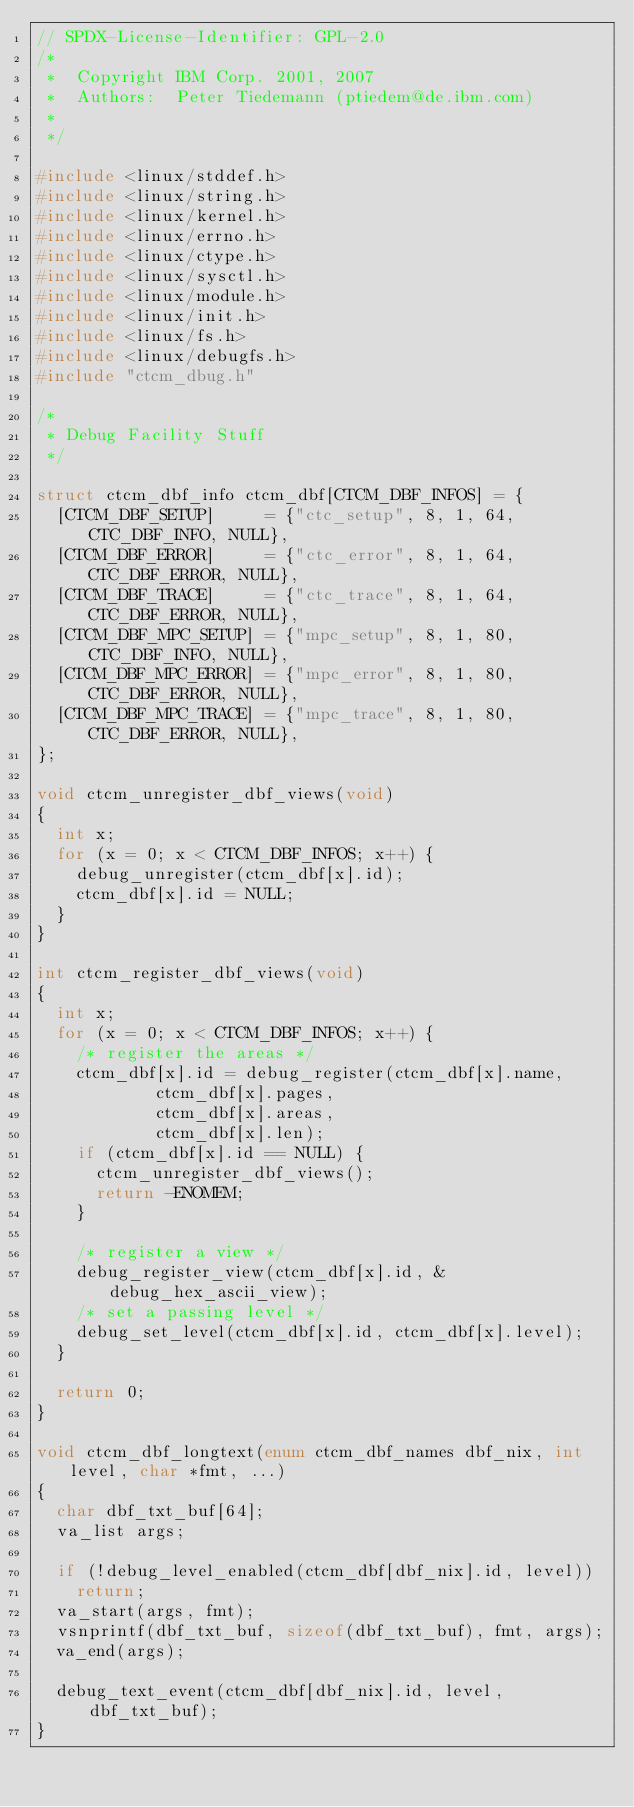<code> <loc_0><loc_0><loc_500><loc_500><_C_>// SPDX-License-Identifier: GPL-2.0
/*
 *	Copyright IBM Corp. 2001, 2007
 *	Authors:	Peter Tiedemann (ptiedem@de.ibm.com)
 *
 */

#include <linux/stddef.h>
#include <linux/string.h>
#include <linux/kernel.h>
#include <linux/errno.h>
#include <linux/ctype.h>
#include <linux/sysctl.h>
#include <linux/module.h>
#include <linux/init.h>
#include <linux/fs.h>
#include <linux/debugfs.h>
#include "ctcm_dbug.h"

/*
 * Debug Facility Stuff
 */

struct ctcm_dbf_info ctcm_dbf[CTCM_DBF_INFOS] = {
	[CTCM_DBF_SETUP]     = {"ctc_setup", 8, 1, 64, CTC_DBF_INFO, NULL},
	[CTCM_DBF_ERROR]     = {"ctc_error", 8, 1, 64, CTC_DBF_ERROR, NULL},
	[CTCM_DBF_TRACE]     = {"ctc_trace", 8, 1, 64, CTC_DBF_ERROR, NULL},
	[CTCM_DBF_MPC_SETUP] = {"mpc_setup", 8, 1, 80, CTC_DBF_INFO, NULL},
	[CTCM_DBF_MPC_ERROR] = {"mpc_error", 8, 1, 80, CTC_DBF_ERROR, NULL},
	[CTCM_DBF_MPC_TRACE] = {"mpc_trace", 8, 1, 80, CTC_DBF_ERROR, NULL},
};

void ctcm_unregister_dbf_views(void)
{
	int x;
	for (x = 0; x < CTCM_DBF_INFOS; x++) {
		debug_unregister(ctcm_dbf[x].id);
		ctcm_dbf[x].id = NULL;
	}
}

int ctcm_register_dbf_views(void)
{
	int x;
	for (x = 0; x < CTCM_DBF_INFOS; x++) {
		/* register the areas */
		ctcm_dbf[x].id = debug_register(ctcm_dbf[x].name,
						ctcm_dbf[x].pages,
						ctcm_dbf[x].areas,
						ctcm_dbf[x].len);
		if (ctcm_dbf[x].id == NULL) {
			ctcm_unregister_dbf_views();
			return -ENOMEM;
		}

		/* register a view */
		debug_register_view(ctcm_dbf[x].id, &debug_hex_ascii_view);
		/* set a passing level */
		debug_set_level(ctcm_dbf[x].id, ctcm_dbf[x].level);
	}

	return 0;
}

void ctcm_dbf_longtext(enum ctcm_dbf_names dbf_nix, int level, char *fmt, ...)
{
	char dbf_txt_buf[64];
	va_list args;

	if (!debug_level_enabled(ctcm_dbf[dbf_nix].id, level))
		return;
	va_start(args, fmt);
	vsnprintf(dbf_txt_buf, sizeof(dbf_txt_buf), fmt, args);
	va_end(args);

	debug_text_event(ctcm_dbf[dbf_nix].id, level, dbf_txt_buf);
}

</code> 